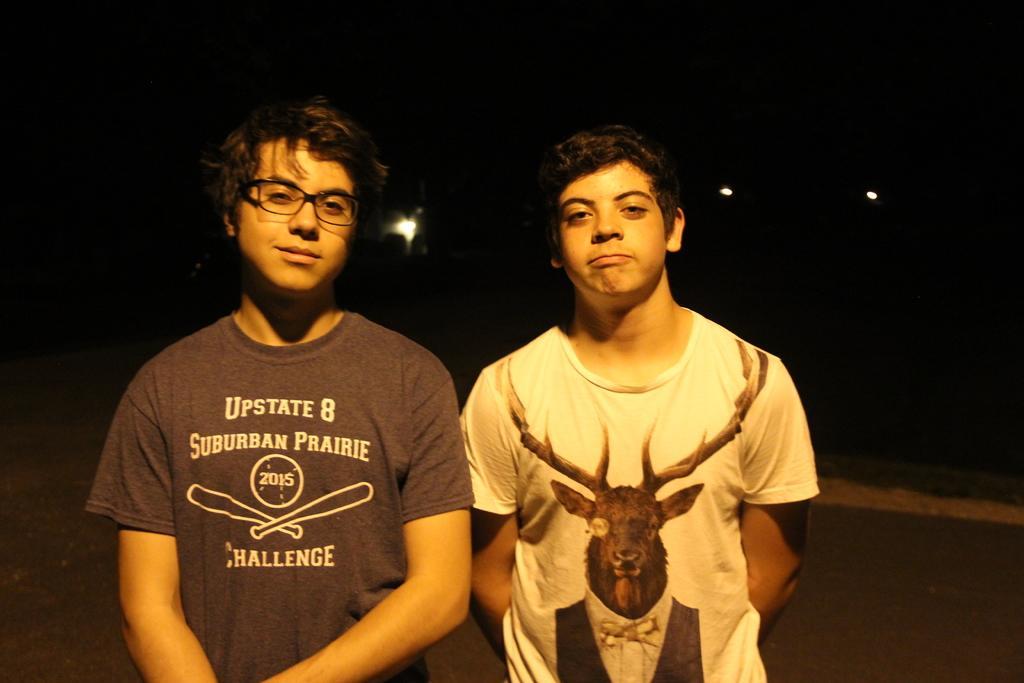Can you describe this image briefly? There are two men standing and smiling. They wore T-shirts. I think these are the lights. The background looks dark. 